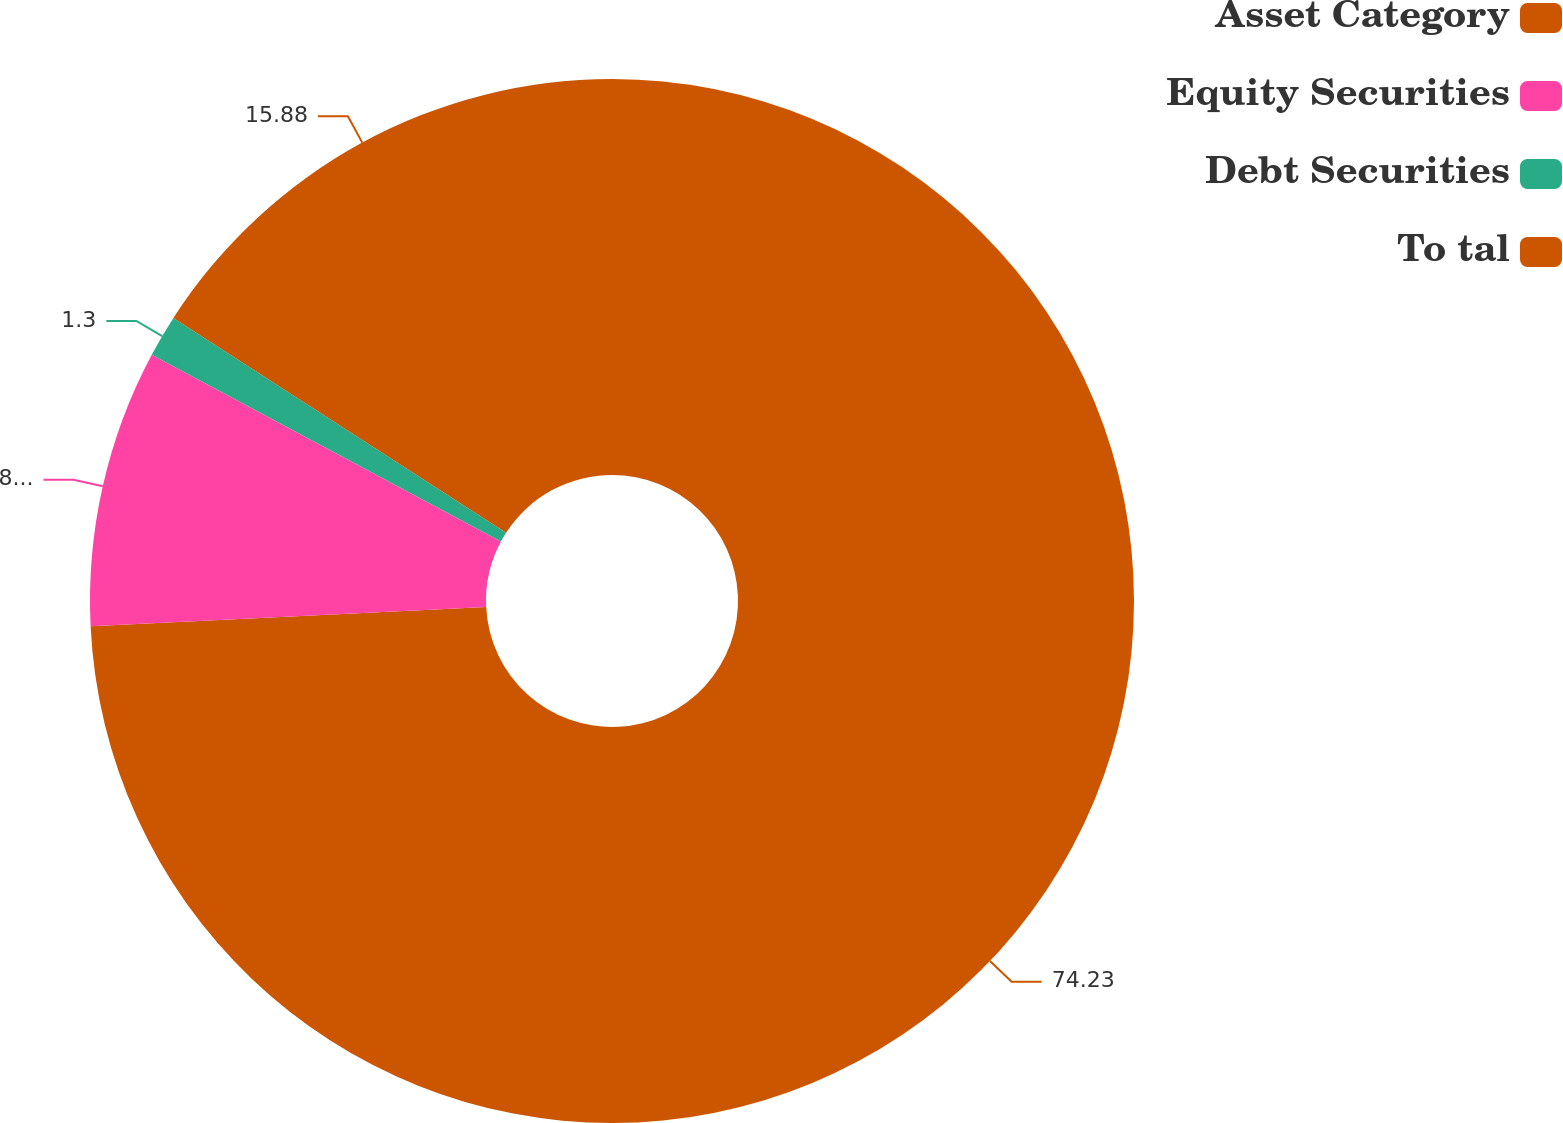Convert chart. <chart><loc_0><loc_0><loc_500><loc_500><pie_chart><fcel>Asset Category<fcel>Equity Securities<fcel>Debt Securities<fcel>To tal<nl><fcel>74.23%<fcel>8.59%<fcel>1.3%<fcel>15.88%<nl></chart> 